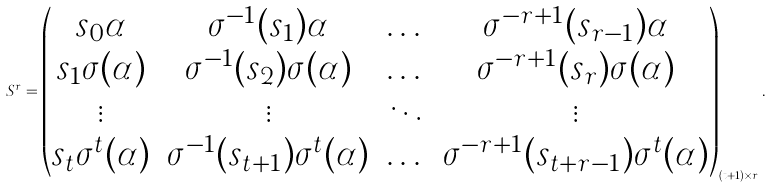<formula> <loc_0><loc_0><loc_500><loc_500>S ^ { r } = \begin{pmatrix} s _ { 0 } \alpha & \sigma ^ { - 1 } ( s _ { 1 } ) \alpha & \dots & \sigma ^ { - r + 1 } ( s _ { r - 1 } ) \alpha \\ s _ { 1 } \sigma ( \alpha ) & \sigma ^ { - 1 } ( s _ { 2 } ) \sigma ( \alpha ) & \dots & \sigma ^ { - r + 1 } ( s _ { r } ) \sigma ( \alpha ) \\ \vdots & \vdots & \ddots & \vdots \\ s _ { t } \sigma ^ { t } ( \alpha ) & \sigma ^ { - 1 } ( s _ { t + 1 } ) \sigma ^ { t } ( \alpha ) & \dots & \sigma ^ { - r + 1 } ( s _ { t + r - 1 } ) \sigma ^ { t } ( \alpha ) \\ \end{pmatrix} _ { ( t + 1 ) \times r } .</formula> 